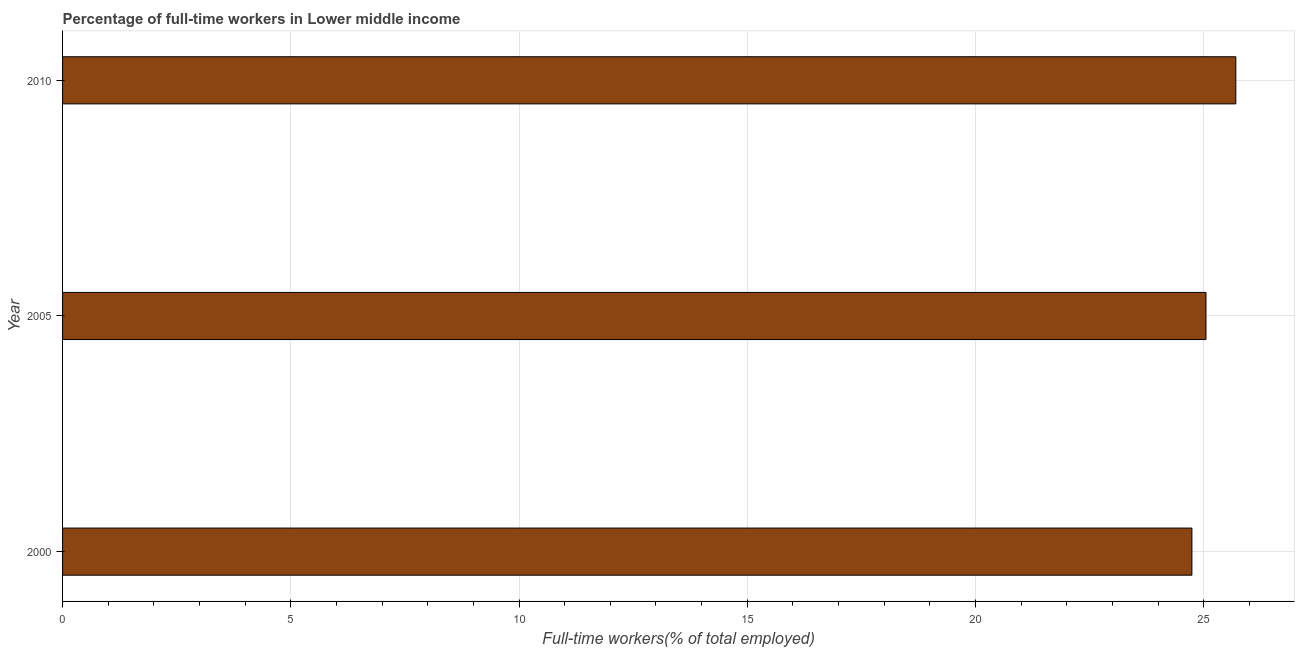Does the graph contain any zero values?
Keep it short and to the point. No. Does the graph contain grids?
Offer a terse response. Yes. What is the title of the graph?
Provide a succinct answer. Percentage of full-time workers in Lower middle income. What is the label or title of the X-axis?
Provide a short and direct response. Full-time workers(% of total employed). What is the label or title of the Y-axis?
Provide a short and direct response. Year. What is the percentage of full-time workers in 2000?
Keep it short and to the point. 24.74. Across all years, what is the maximum percentage of full-time workers?
Ensure brevity in your answer.  25.7. Across all years, what is the minimum percentage of full-time workers?
Offer a terse response. 24.74. In which year was the percentage of full-time workers minimum?
Offer a very short reply. 2000. What is the sum of the percentage of full-time workers?
Make the answer very short. 75.5. What is the difference between the percentage of full-time workers in 2005 and 2010?
Provide a succinct answer. -0.65. What is the average percentage of full-time workers per year?
Your response must be concise. 25.17. What is the median percentage of full-time workers?
Give a very brief answer. 25.05. Do a majority of the years between 2000 and 2010 (inclusive) have percentage of full-time workers greater than 11 %?
Your answer should be very brief. Yes. What is the ratio of the percentage of full-time workers in 2000 to that in 2005?
Keep it short and to the point. 0.99. What is the difference between the highest and the second highest percentage of full-time workers?
Your response must be concise. 0.65. Is the sum of the percentage of full-time workers in 2005 and 2010 greater than the maximum percentage of full-time workers across all years?
Keep it short and to the point. Yes. How many bars are there?
Provide a short and direct response. 3. Are all the bars in the graph horizontal?
Give a very brief answer. Yes. How many years are there in the graph?
Your answer should be very brief. 3. Are the values on the major ticks of X-axis written in scientific E-notation?
Give a very brief answer. No. What is the Full-time workers(% of total employed) of 2000?
Offer a very short reply. 24.74. What is the Full-time workers(% of total employed) of 2005?
Give a very brief answer. 25.05. What is the Full-time workers(% of total employed) of 2010?
Your response must be concise. 25.7. What is the difference between the Full-time workers(% of total employed) in 2000 and 2005?
Provide a short and direct response. -0.31. What is the difference between the Full-time workers(% of total employed) in 2000 and 2010?
Offer a terse response. -0.96. What is the difference between the Full-time workers(% of total employed) in 2005 and 2010?
Your answer should be very brief. -0.65. What is the ratio of the Full-time workers(% of total employed) in 2000 to that in 2005?
Your answer should be very brief. 0.99. What is the ratio of the Full-time workers(% of total employed) in 2005 to that in 2010?
Offer a terse response. 0.97. 